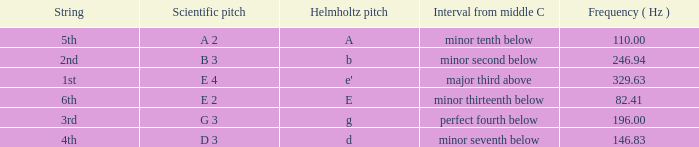What is the lowest Frequency where the Hemholtz pitch is d? 146.83. 